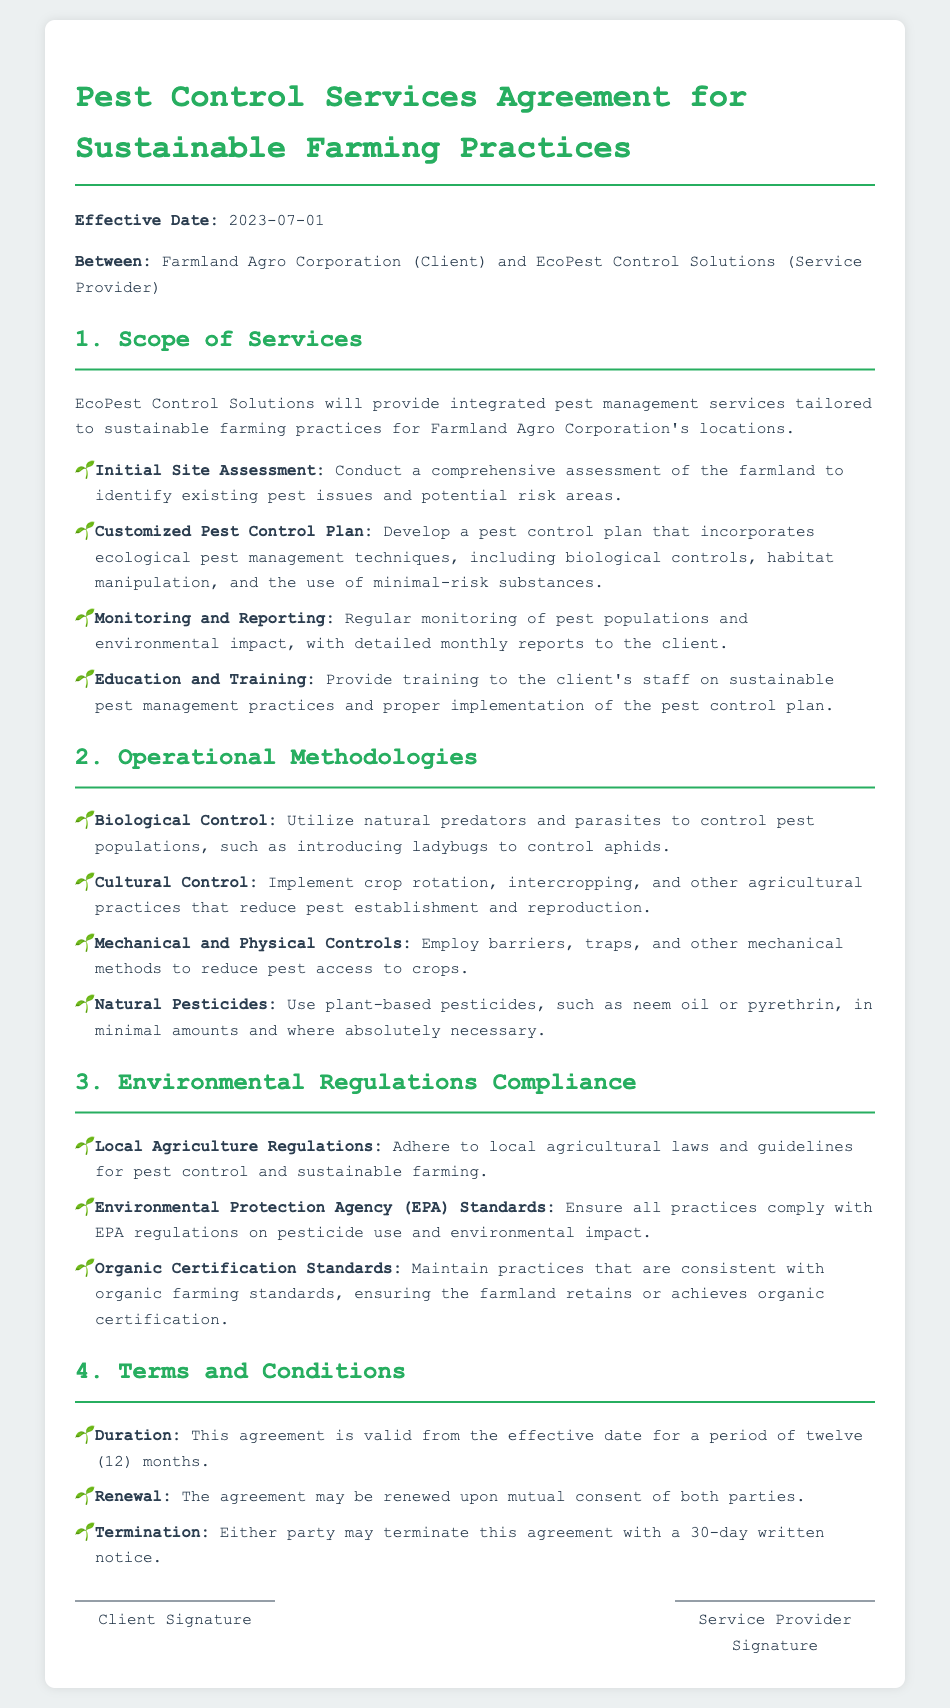What is the effective date of the contract? The effective date is mentioned at the beginning of the document as 2023-07-01.
Answer: 2023-07-01 Who is the service provider? The service provider is named in the document as EcoPest Control Solutions.
Answer: EcoPest Control Solutions How long is the duration of the agreement? The duration is specified in Section 4 as twelve (12) months.
Answer: twelve (12) months What type of pest management services will be provided? The document states that integrated pest management services will be provided.
Answer: integrated pest management services What must be adhered to according to environmental regulations? The document specifies compliance with local agriculture laws and EPA standards.
Answer: local agriculture laws and EPA standards Which techniques are included in the customized pest control plan? The plan includes ecological pest management techniques as outlined in Section 1.
Answer: ecological pest management techniques What must terminate the agreement? The agreement can be terminated with a 30-day written notice from either party.
Answer: 30-day written notice What training will be provided to the client's staff? The staff will receive training on sustainable pest management practices.
Answer: sustainable pest management practices What is required for organic certification? Practices must be consistent with organic farming standards, according to Section 3.
Answer: consistent with organic farming standards 